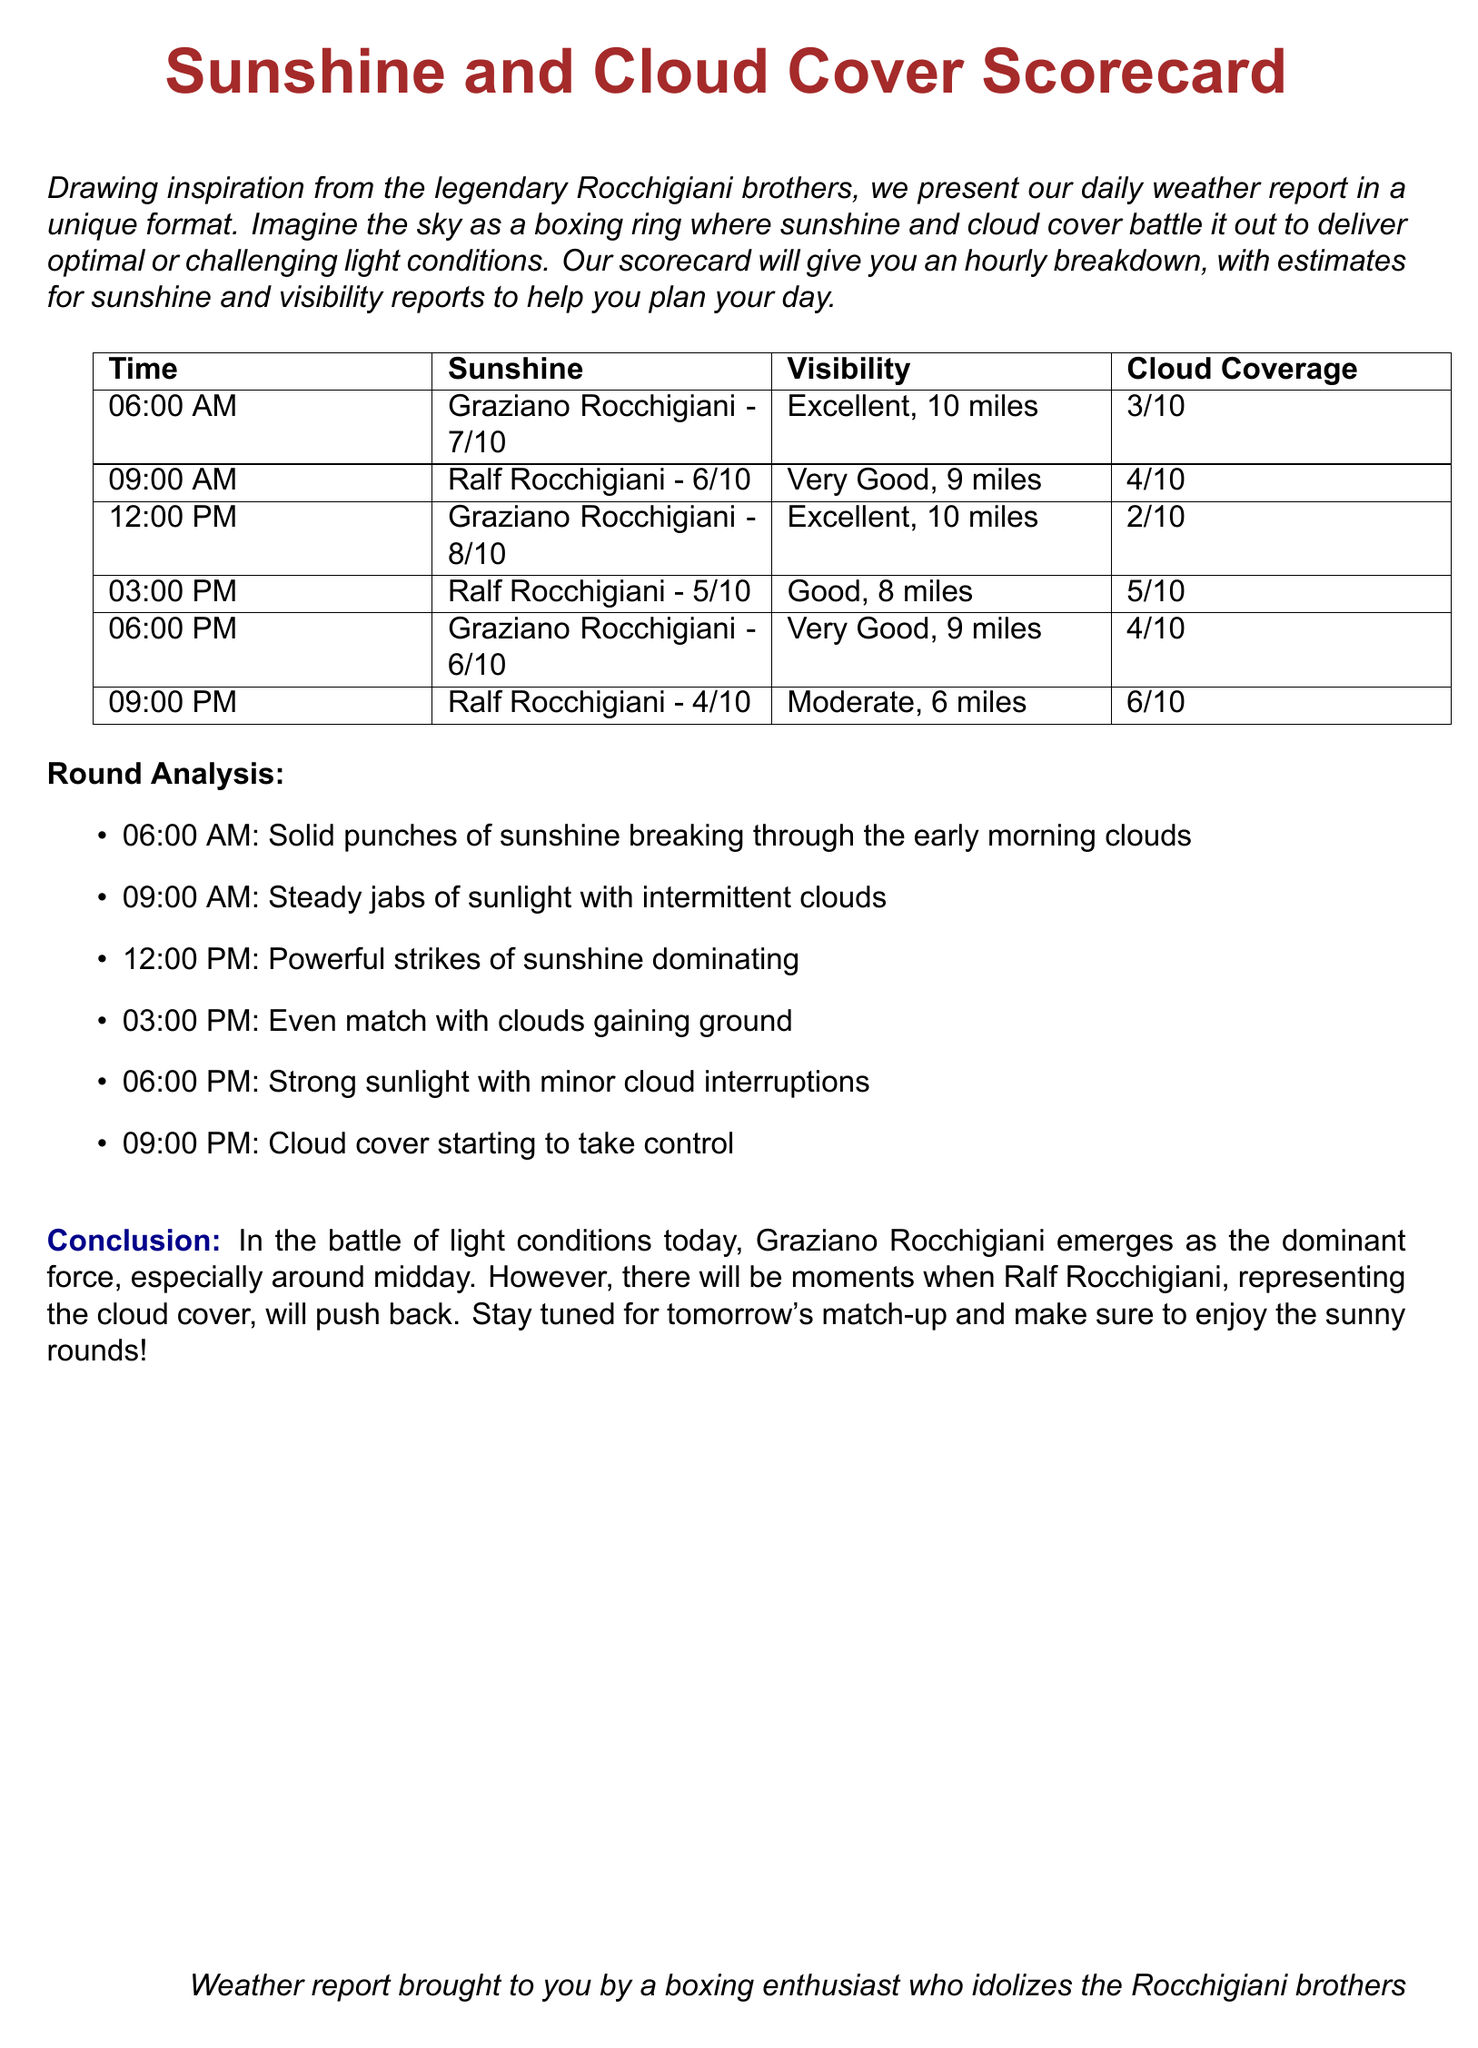what time had the highest sunshine score? The highest sunshine score of 8/10 occurred at 12:00 PM.
Answer: 12:00 PM what was the cloud coverage at 06:00 AM? The cloud coverage at 06:00 AM was 3/10.
Answer: 3/10 how many miles visibility was reported at 09:00 PM? The visibility reported at 09:00 PM was 6 miles.
Answer: 6 miles which Rocchigiani brother had the highest score at 12:00 PM? Graziano Rocchigiani had the highest score of 8/10 at 12:00 PM.
Answer: Graziano Rocchigiani what was the average cloud coverage throughout the day? The average cloud coverage is calculated by averaging all scores: (3 + 4 + 2 + 5 + 4 + 6) / 6 = 4.
Answer: 4 who had a score of 4/10 at 09:00 PM? Ralf Rocchigiani had a score of 4/10 at 09:00 PM.
Answer: Ralf Rocchigiani how did the sunshine score change from 03:00 PM to 06:00 PM? The sunshine score changed from 5/10 at 03:00 PM to 6/10 at 06:00 PM.
Answer: Increased which time had excellent visibility? Both 06:00 AM and 12:00 PM had excellent visibility of 10 miles.
Answer: 06:00 AM and 12:00 PM what is the main theme of the weather report? The theme is about evaluating sunshine and cloud cover like a boxing match.
Answer: Boxing match 